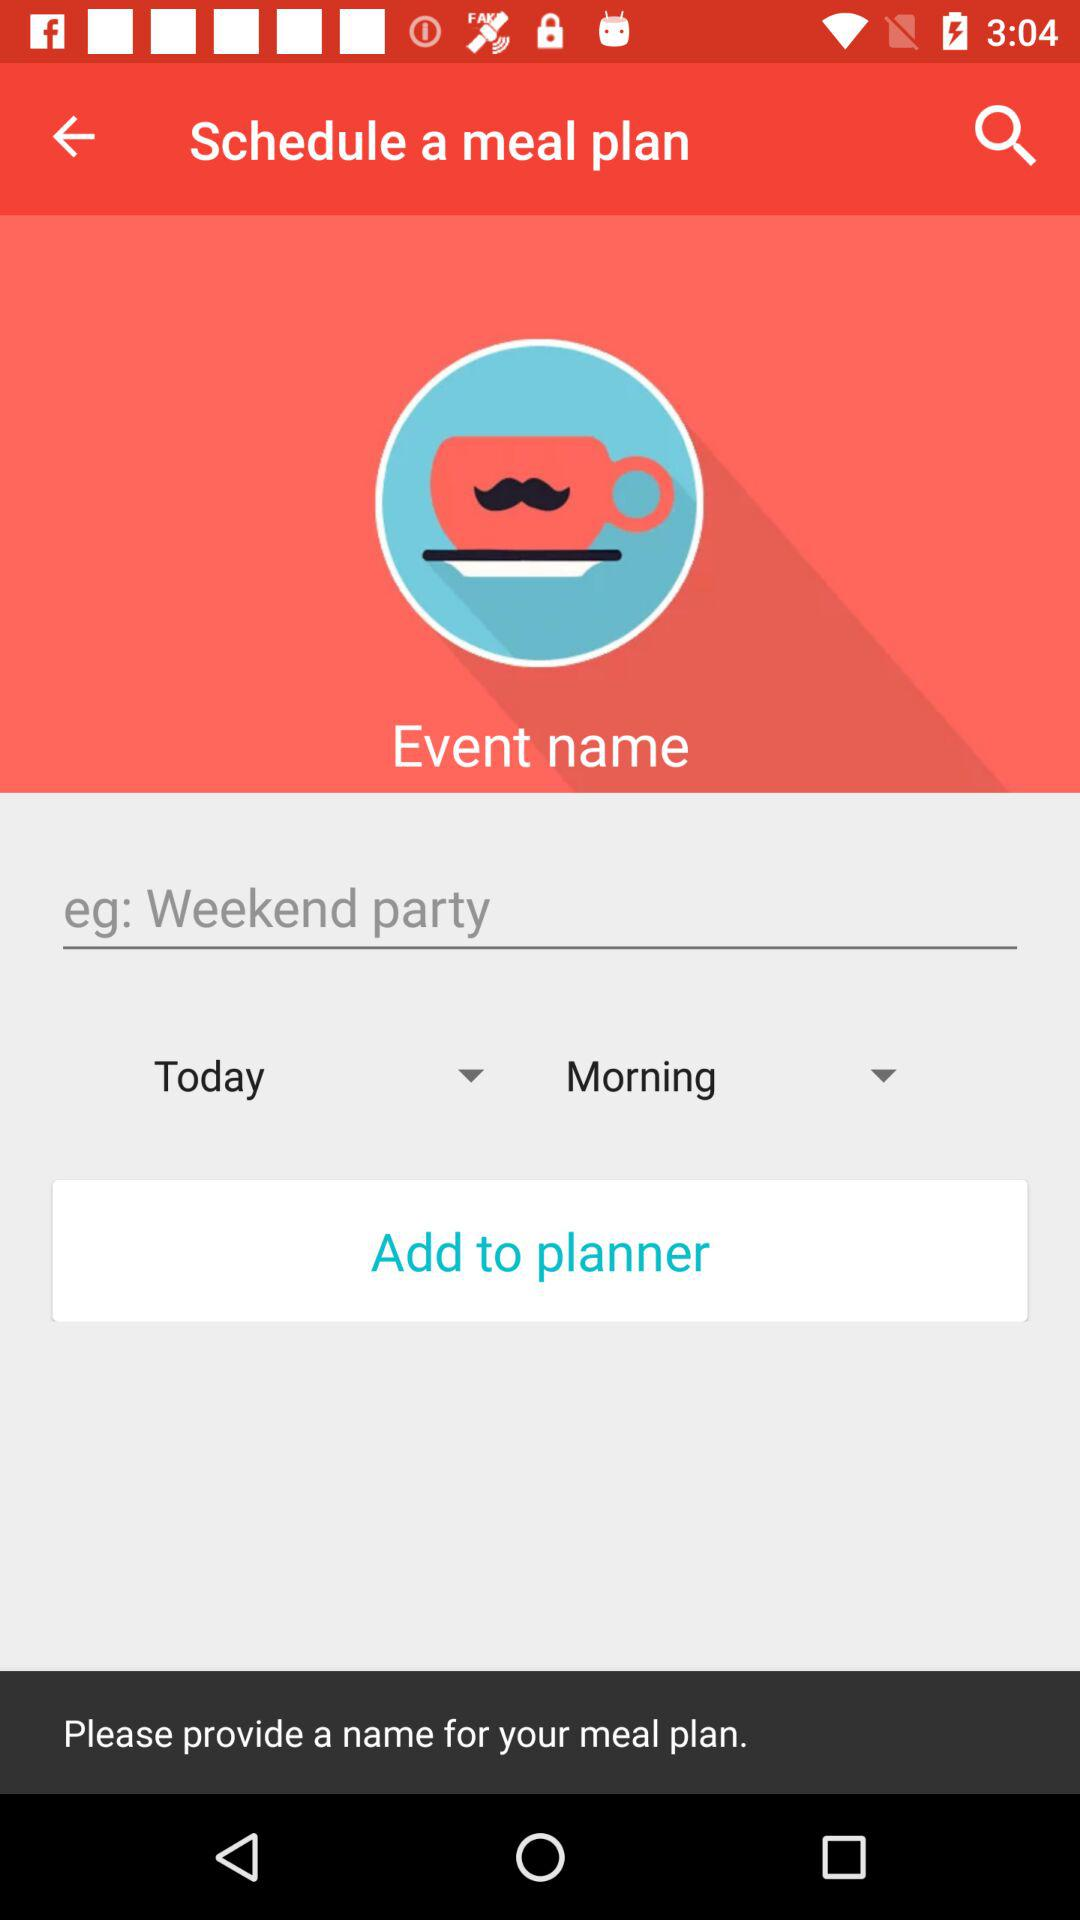What is the given example? The given example is a weekend party. 